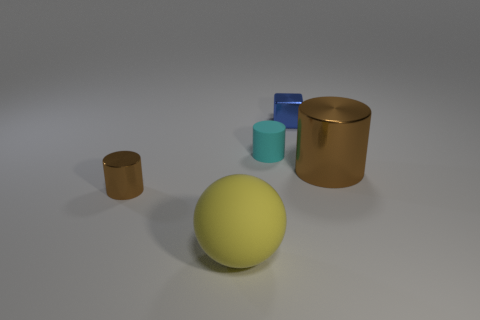Are there fewer yellow balls that are in front of the big yellow object than small red metal balls?
Provide a succinct answer. No. There is a matte thing behind the small object in front of the brown cylinder to the right of the small blue shiny object; how big is it?
Make the answer very short. Small. What is the color of the object that is behind the big brown thing and left of the tiny blue metallic object?
Your answer should be very brief. Cyan. How many large objects are there?
Ensure brevity in your answer.  2. Does the blue block have the same material as the large cylinder?
Give a very brief answer. Yes. There is a shiny object that is left of the small cube; is it the same size as the brown shiny cylinder that is on the right side of the yellow rubber thing?
Your answer should be very brief. No. Is the number of large shiny objects less than the number of tiny blue matte cylinders?
Provide a succinct answer. No. What number of metal objects are tiny cyan cylinders or big yellow objects?
Make the answer very short. 0. Are there any metal things that are left of the blue object behind the large metallic cylinder?
Your answer should be very brief. Yes. Are the tiny thing left of the large matte thing and the cube made of the same material?
Your answer should be compact. Yes. 